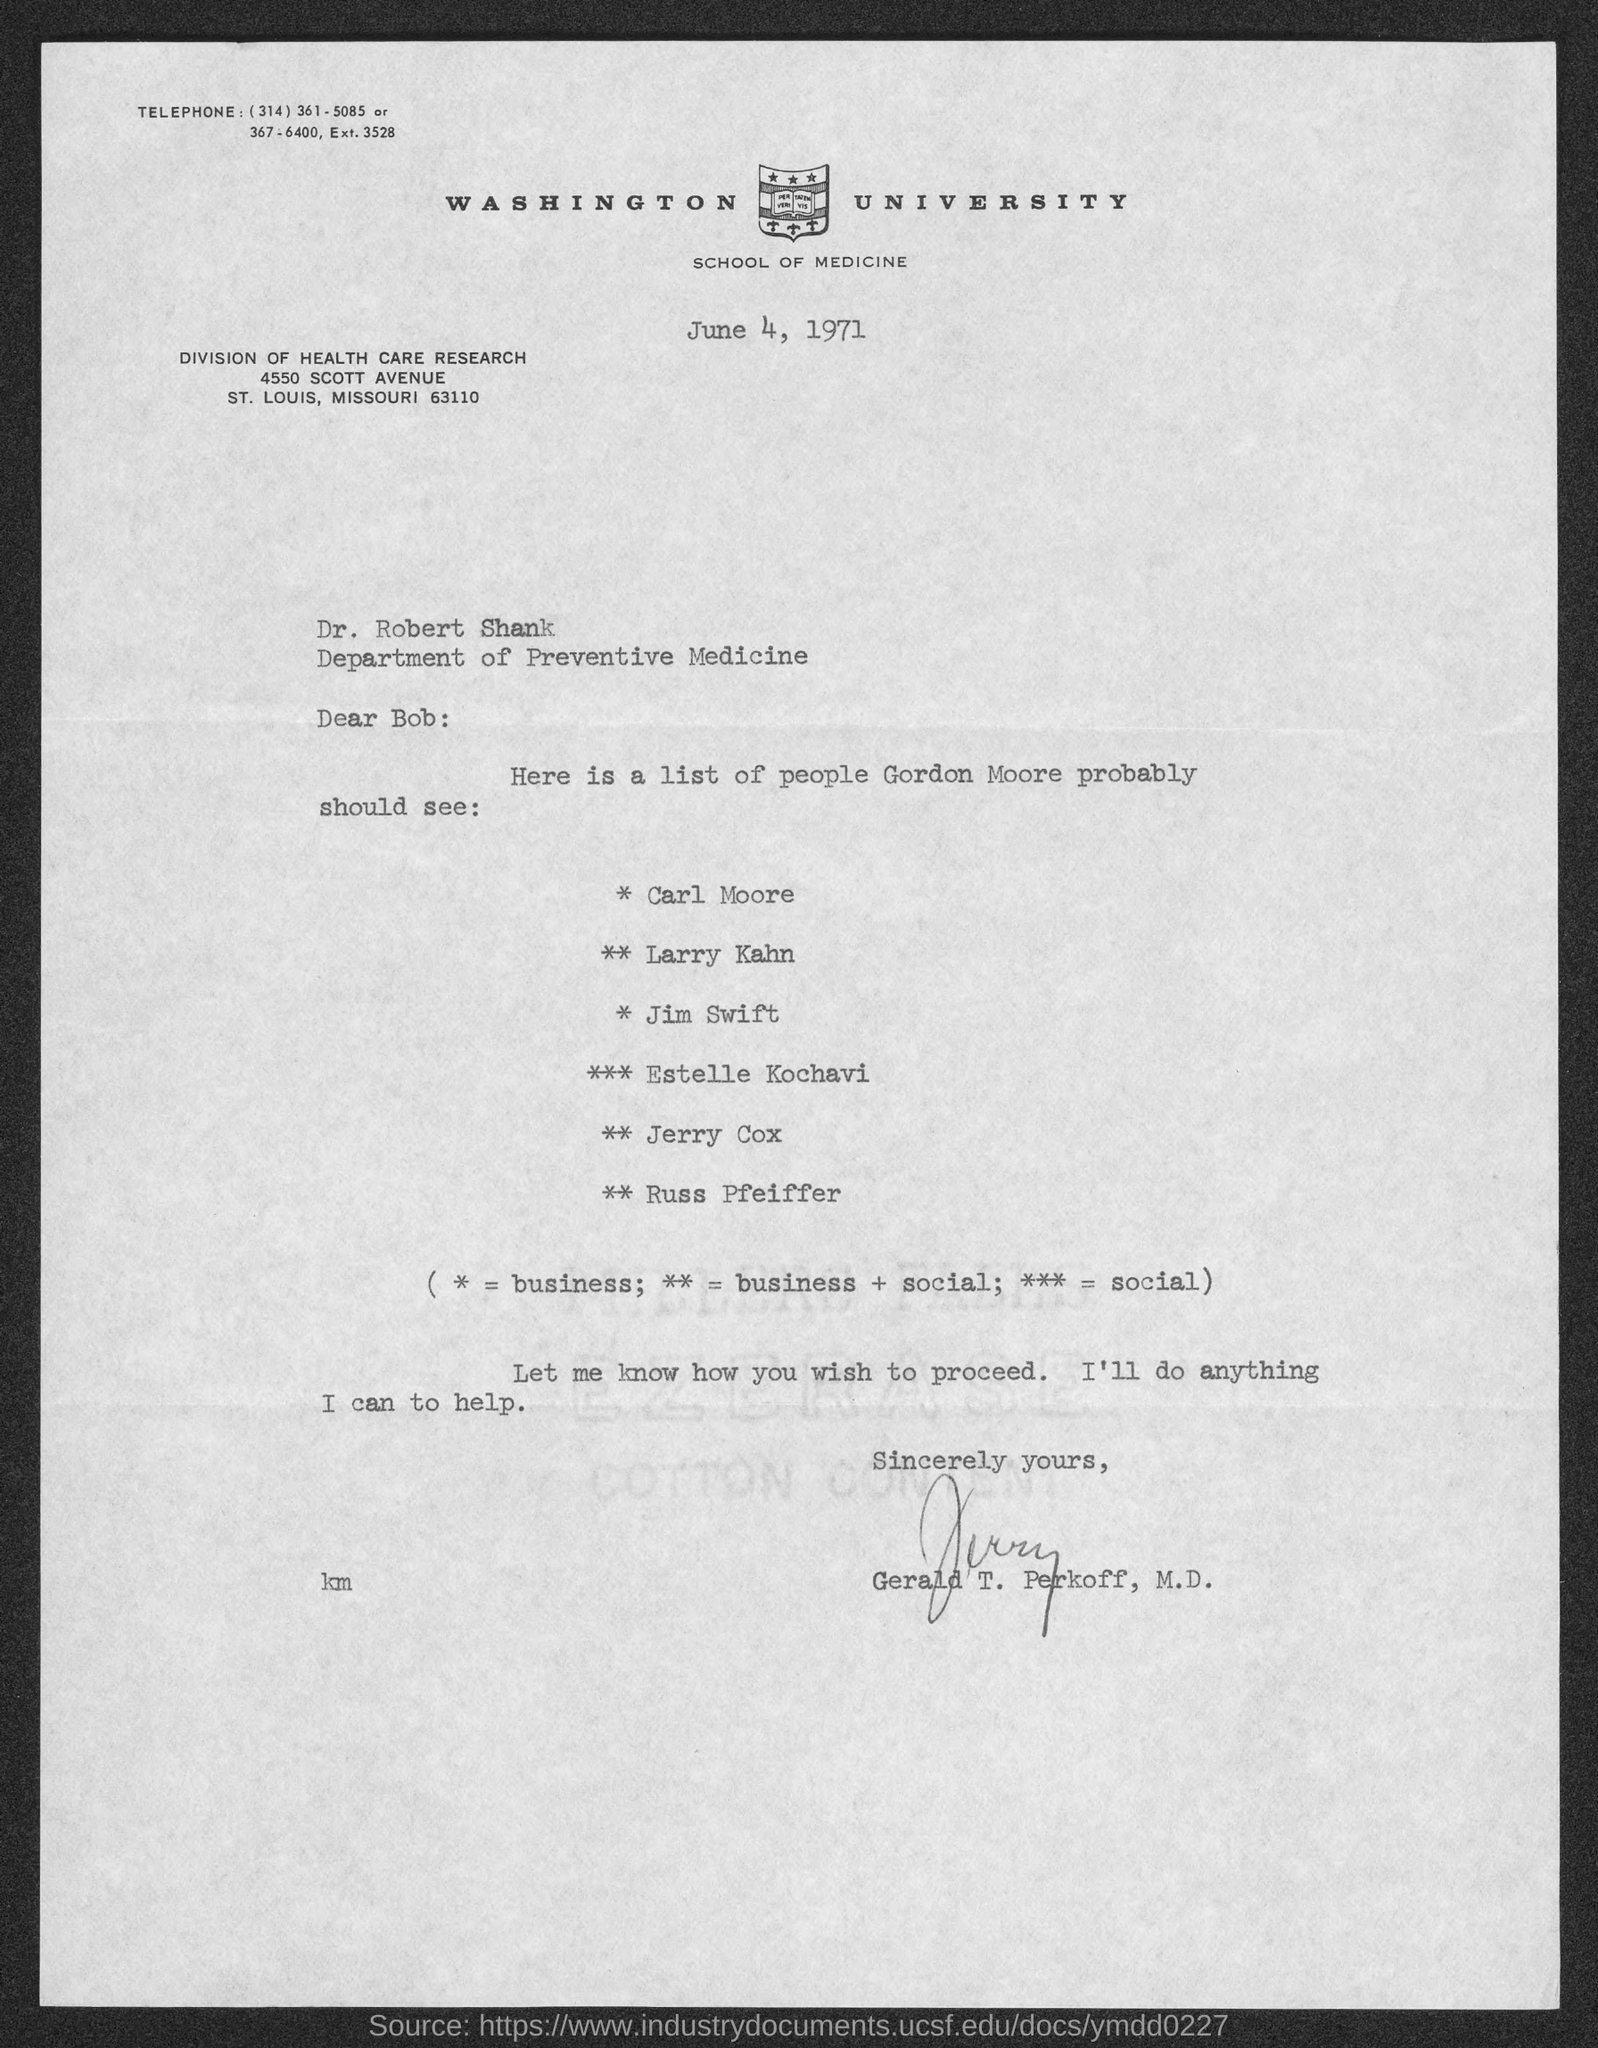Specify some key components in this picture. Gordon Moore should seek the professional services of Estelle Kochavi for social. The acronym ** stands for business and social, representing a combination of both aspects in a single entity. Gerald T. Perkoff has signed the letter. The document is dated June 4, 1971. The letter is addressed to Bob. 